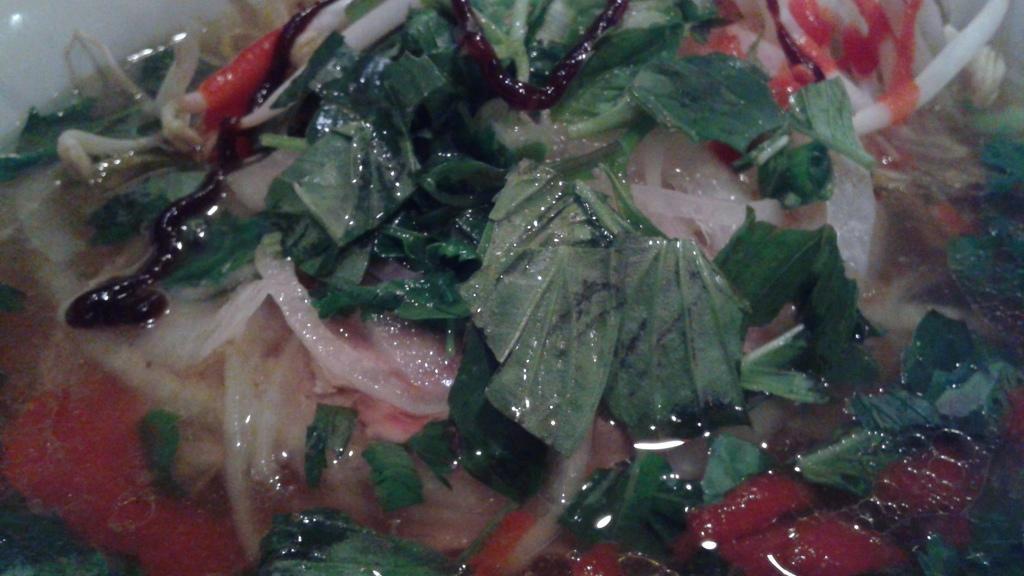In one or two sentences, can you explain what this image depicts? In this picture we can see leaves, water and some food items. 